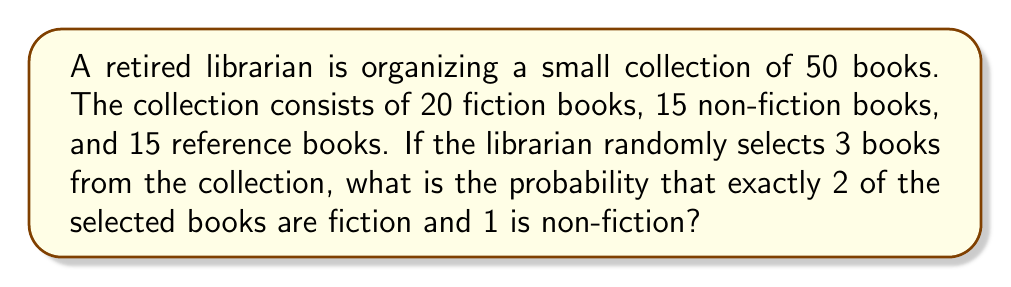What is the answer to this math problem? Let's approach this step-by-step using combinatorics:

1) First, we need to calculate the total number of ways to select 3 books from 50. This is given by the combination formula:

   $${50 \choose 3} = \frac{50!}{3!(50-3)!} = \frac{50!}{3!47!} = 19,600$$

2) Now, we need to calculate the number of ways to select 2 fiction books and 1 non-fiction book:
   
   a) Select 2 fiction books from 20: $${20 \choose 2} = \frac{20!}{2!18!} = 190$$
   
   b) Select 1 non-fiction book from 15: $${15 \choose 1} = 15$$

3) Multiply these together to get the total number of favorable outcomes:

   $$190 \times 15 = 2,850$$

4) The probability is then the number of favorable outcomes divided by the total number of possible outcomes:

   $$P(\text{2 fiction, 1 non-fiction}) = \frac{2,850}{19,600} = \frac{57}{392} \approx 0.1454$$
Answer: $\frac{57}{392}$ 